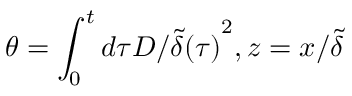<formula> <loc_0><loc_0><loc_500><loc_500>\theta = \int _ { 0 } ^ { t } { d \tau D / { \tilde { \delta } ( \tau ) } ^ { 2 } } , z = x / \tilde { \delta }</formula> 